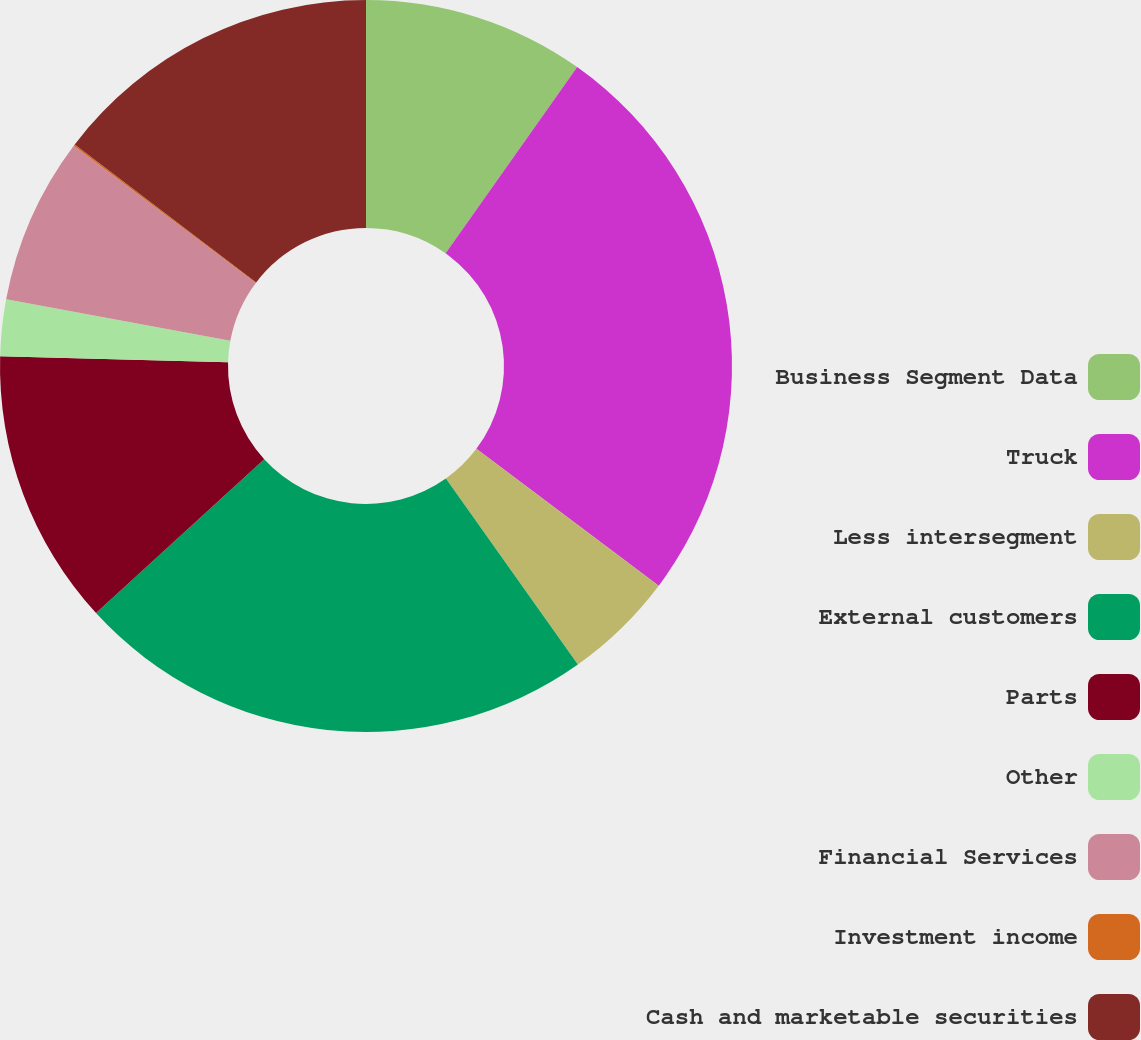Convert chart. <chart><loc_0><loc_0><loc_500><loc_500><pie_chart><fcel>Business Segment Data<fcel>Truck<fcel>Less intersegment<fcel>External customers<fcel>Parts<fcel>Other<fcel>Financial Services<fcel>Investment income<fcel>Cash and marketable securities<nl><fcel>9.79%<fcel>25.46%<fcel>4.93%<fcel>23.03%<fcel>12.22%<fcel>2.5%<fcel>7.36%<fcel>0.07%<fcel>14.65%<nl></chart> 